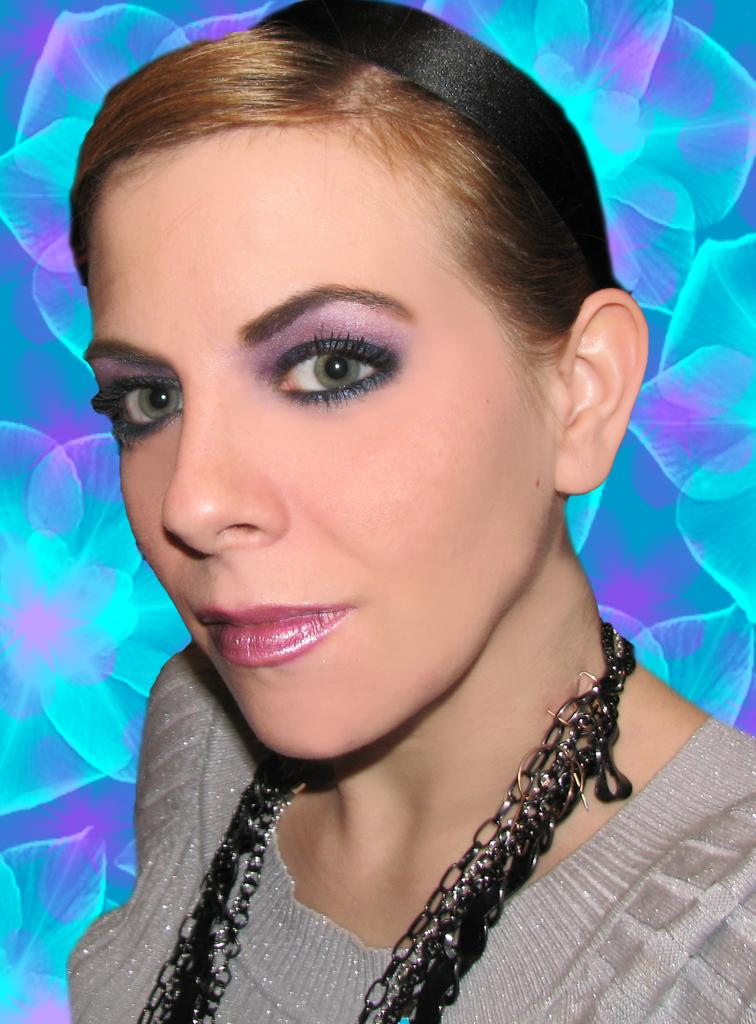Who is present in the image? There is a woman in the image. What is the woman wearing in the image? The woman is wearing a necklace in the image. Can you describe the background of the image? The background of the image has a design. What type of field can be seen in the image? There is no field present in the image. How many giants are visible in the image? There are no giants present in the image. 